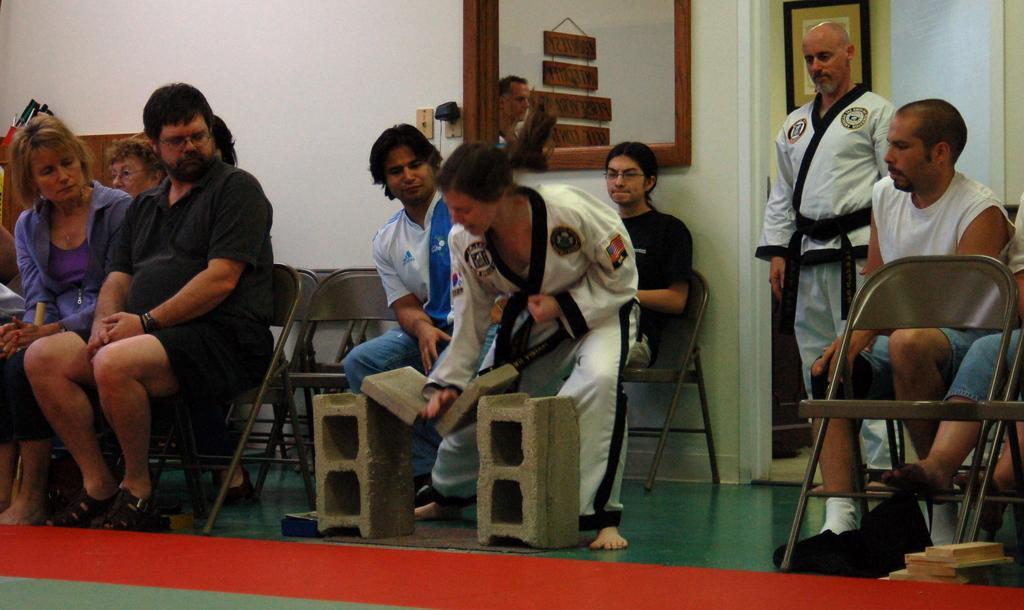Can you describe this image briefly? In the image some people are sitting on the chairs and in between them a woman is breaking the bricks,she is wearing karate costume and in the background there is a wall and a mirror is attached to the wall. 